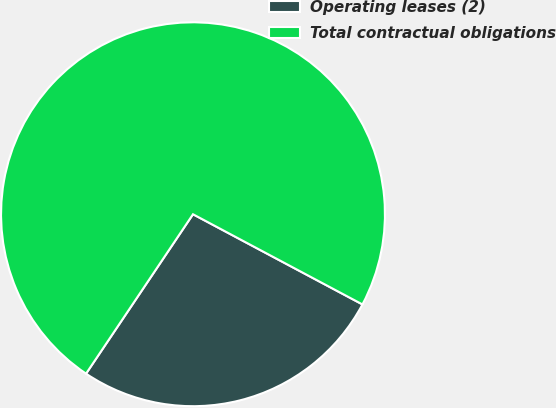<chart> <loc_0><loc_0><loc_500><loc_500><pie_chart><fcel>Operating leases (2)<fcel>Total contractual obligations<nl><fcel>26.62%<fcel>73.38%<nl></chart> 